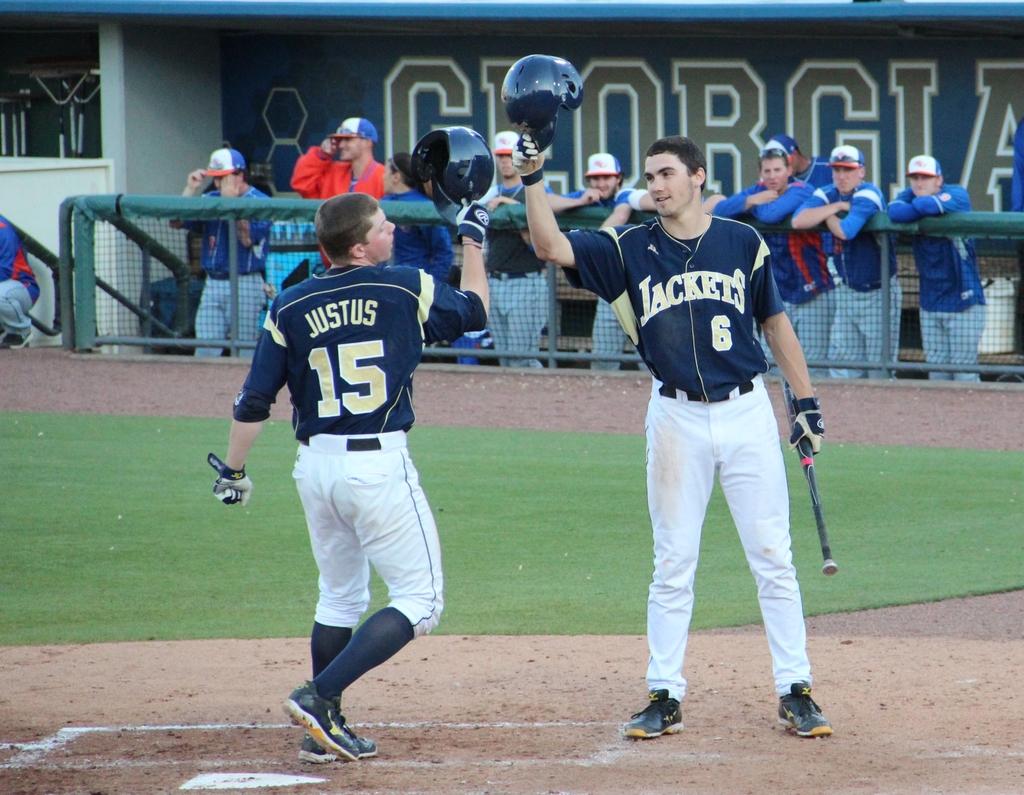What is the name of the batter's team?
Ensure brevity in your answer.  Jackets. 